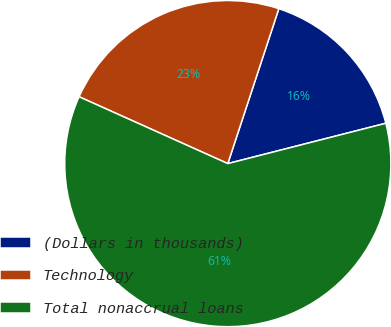<chart> <loc_0><loc_0><loc_500><loc_500><pie_chart><fcel>(Dollars in thousands)<fcel>Technology<fcel>Total nonaccrual loans<nl><fcel>15.96%<fcel>23.34%<fcel>60.7%<nl></chart> 